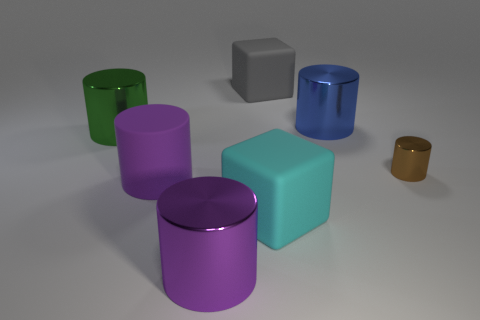Do the large thing that is on the right side of the cyan rubber cube and the big block that is behind the blue object have the same material?
Your answer should be very brief. No. Is the number of purple cylinders in front of the green thing the same as the number of small objects to the left of the cyan rubber object?
Your answer should be very brief. No. How many objects have the same material as the blue cylinder?
Provide a short and direct response. 3. There is a big object that is the same color as the big rubber cylinder; what shape is it?
Your response must be concise. Cylinder. What is the size of the brown metal object that is on the right side of the big cylinder on the left side of the large purple rubber cylinder?
Give a very brief answer. Small. There is a object that is on the left side of the purple matte cylinder; does it have the same shape as the big metal thing that is in front of the brown thing?
Offer a terse response. Yes. Are there an equal number of purple cylinders that are behind the large cyan cube and big green cylinders?
Give a very brief answer. Yes. What is the color of the other tiny object that is the same shape as the blue metal thing?
Your response must be concise. Brown. Is the gray object on the right side of the large green metal cylinder made of the same material as the big green cylinder?
Your answer should be compact. No. How many large objects are cyan matte things or red shiny balls?
Give a very brief answer. 1. 